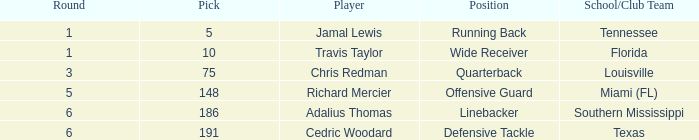What is the highest round louisville reached when their selection exceeded 75? None. 